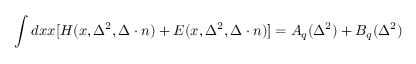Convert formula to latex. <formula><loc_0><loc_0><loc_500><loc_500>\int d x x [ H ( x , \Delta ^ { 2 } , \Delta \cdot n ) + E ( x , \Delta ^ { 2 } , \Delta \cdot n ) ] = A _ { q } ( \Delta ^ { 2 } ) + B _ { q } ( \Delta ^ { 2 } )</formula> 